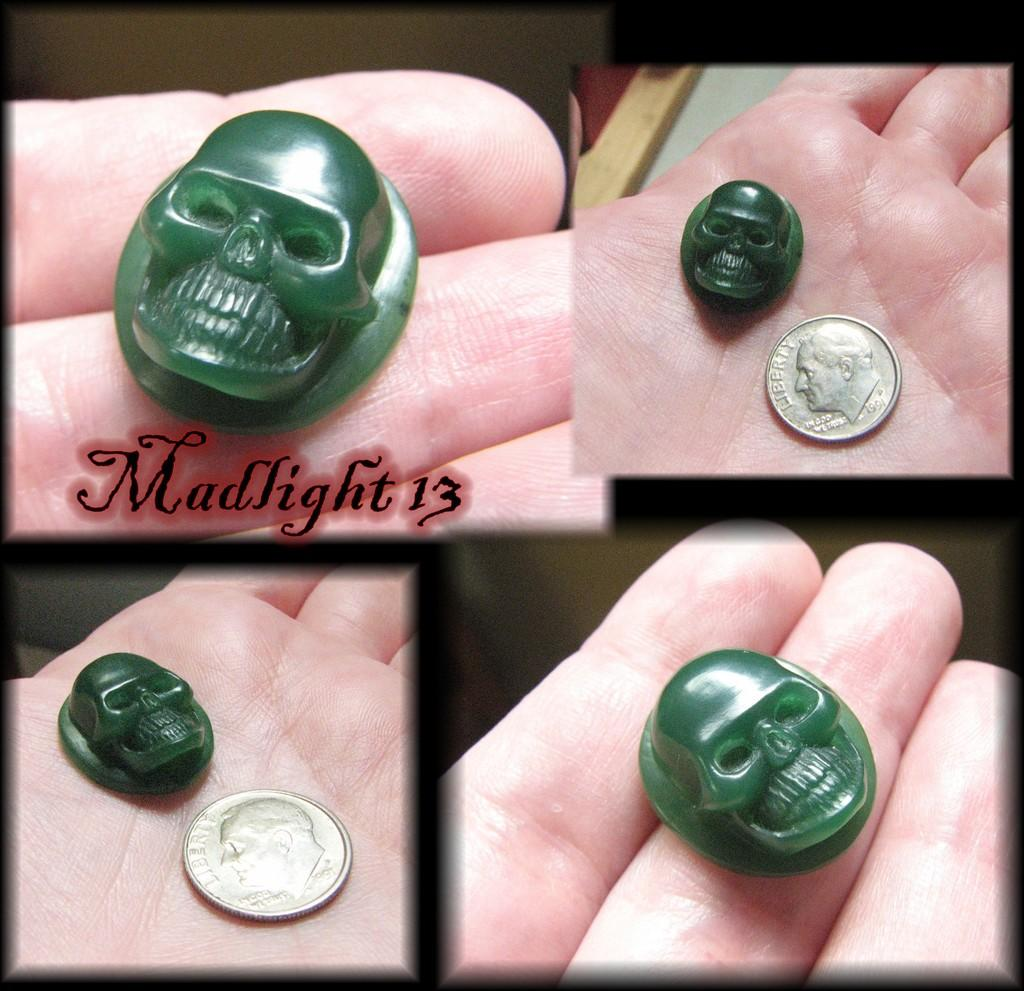What type of artwork is depicted in the image? The image is a collage. Can you describe any objects present in the collage? Yes, there is an object in the collage. What is happening with the coin in the collage? The coin is on a person's hand in the collage. Are there any words or letters in the collage? Yes, there is text in the collage. What type of heart-shaped sticks can be seen in the image? There is no mention of heart-shaped sticks in the image; the facts provided do not include any information about sticks or a heart shape. 